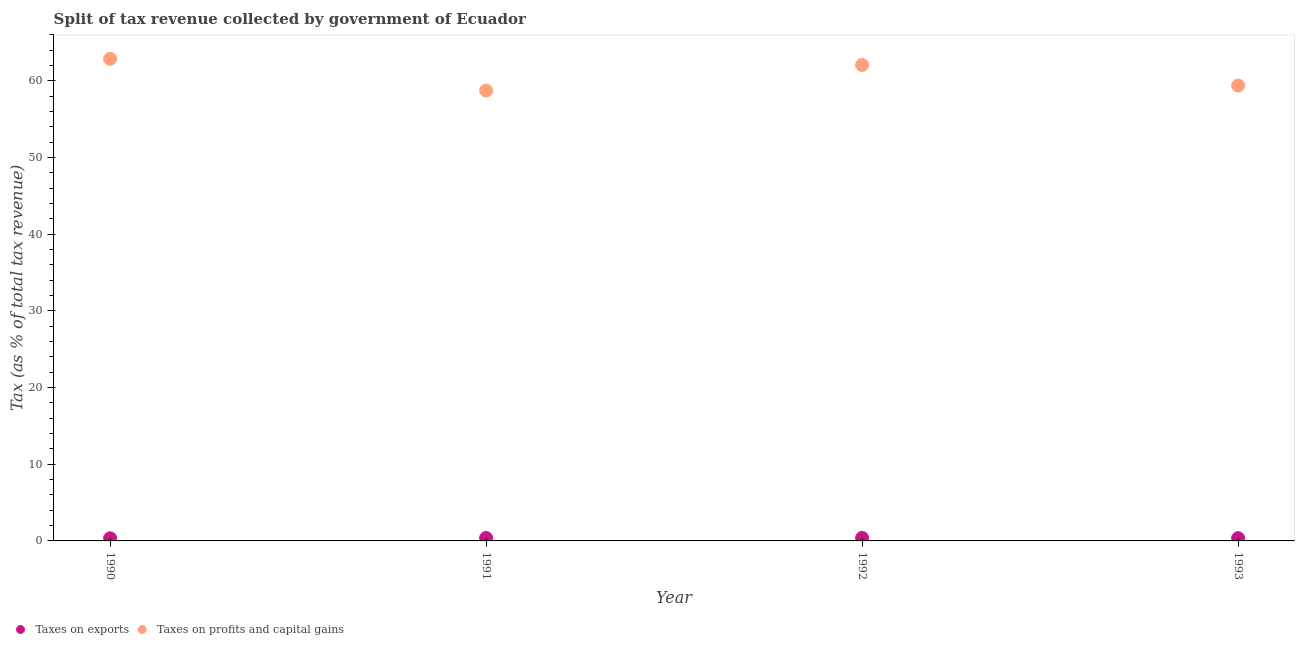How many different coloured dotlines are there?
Your answer should be compact. 2. Is the number of dotlines equal to the number of legend labels?
Your response must be concise. Yes. What is the percentage of revenue obtained from taxes on profits and capital gains in 1991?
Give a very brief answer. 58.74. Across all years, what is the maximum percentage of revenue obtained from taxes on profits and capital gains?
Your answer should be compact. 62.88. Across all years, what is the minimum percentage of revenue obtained from taxes on exports?
Your answer should be very brief. 0.34. In which year was the percentage of revenue obtained from taxes on profits and capital gains minimum?
Make the answer very short. 1991. What is the total percentage of revenue obtained from taxes on profits and capital gains in the graph?
Provide a short and direct response. 243.09. What is the difference between the percentage of revenue obtained from taxes on exports in 1990 and that in 1992?
Your response must be concise. -0.05. What is the difference between the percentage of revenue obtained from taxes on profits and capital gains in 1993 and the percentage of revenue obtained from taxes on exports in 1992?
Provide a succinct answer. 59. What is the average percentage of revenue obtained from taxes on profits and capital gains per year?
Keep it short and to the point. 60.77. In the year 1991, what is the difference between the percentage of revenue obtained from taxes on profits and capital gains and percentage of revenue obtained from taxes on exports?
Provide a succinct answer. 58.36. In how many years, is the percentage of revenue obtained from taxes on profits and capital gains greater than 4 %?
Provide a short and direct response. 4. What is the ratio of the percentage of revenue obtained from taxes on exports in 1992 to that in 1993?
Give a very brief answer. 1.1. Is the percentage of revenue obtained from taxes on exports in 1992 less than that in 1993?
Your response must be concise. No. What is the difference between the highest and the second highest percentage of revenue obtained from taxes on profits and capital gains?
Keep it short and to the point. 0.8. What is the difference between the highest and the lowest percentage of revenue obtained from taxes on profits and capital gains?
Your response must be concise. 4.14. Is the sum of the percentage of revenue obtained from taxes on profits and capital gains in 1990 and 1991 greater than the maximum percentage of revenue obtained from taxes on exports across all years?
Your answer should be compact. Yes. Does the percentage of revenue obtained from taxes on profits and capital gains monotonically increase over the years?
Ensure brevity in your answer.  No. Is the percentage of revenue obtained from taxes on exports strictly greater than the percentage of revenue obtained from taxes on profits and capital gains over the years?
Ensure brevity in your answer.  No. Is the percentage of revenue obtained from taxes on exports strictly less than the percentage of revenue obtained from taxes on profits and capital gains over the years?
Give a very brief answer. Yes. How many dotlines are there?
Provide a succinct answer. 2. How many years are there in the graph?
Make the answer very short. 4. Does the graph contain any zero values?
Offer a terse response. No. Where does the legend appear in the graph?
Ensure brevity in your answer.  Bottom left. What is the title of the graph?
Offer a very short reply. Split of tax revenue collected by government of Ecuador. What is the label or title of the Y-axis?
Give a very brief answer. Tax (as % of total tax revenue). What is the Tax (as % of total tax revenue) in Taxes on exports in 1990?
Offer a terse response. 0.34. What is the Tax (as % of total tax revenue) in Taxes on profits and capital gains in 1990?
Your response must be concise. 62.88. What is the Tax (as % of total tax revenue) in Taxes on exports in 1991?
Provide a short and direct response. 0.38. What is the Tax (as % of total tax revenue) of Taxes on profits and capital gains in 1991?
Offer a very short reply. 58.74. What is the Tax (as % of total tax revenue) in Taxes on exports in 1992?
Ensure brevity in your answer.  0.4. What is the Tax (as % of total tax revenue) of Taxes on profits and capital gains in 1992?
Offer a terse response. 62.08. What is the Tax (as % of total tax revenue) of Taxes on exports in 1993?
Your answer should be compact. 0.36. What is the Tax (as % of total tax revenue) of Taxes on profits and capital gains in 1993?
Ensure brevity in your answer.  59.4. Across all years, what is the maximum Tax (as % of total tax revenue) of Taxes on exports?
Keep it short and to the point. 0.4. Across all years, what is the maximum Tax (as % of total tax revenue) in Taxes on profits and capital gains?
Make the answer very short. 62.88. Across all years, what is the minimum Tax (as % of total tax revenue) of Taxes on exports?
Your answer should be compact. 0.34. Across all years, what is the minimum Tax (as % of total tax revenue) of Taxes on profits and capital gains?
Your response must be concise. 58.74. What is the total Tax (as % of total tax revenue) of Taxes on exports in the graph?
Provide a succinct answer. 1.48. What is the total Tax (as % of total tax revenue) in Taxes on profits and capital gains in the graph?
Ensure brevity in your answer.  243.09. What is the difference between the Tax (as % of total tax revenue) in Taxes on exports in 1990 and that in 1991?
Offer a terse response. -0.04. What is the difference between the Tax (as % of total tax revenue) of Taxes on profits and capital gains in 1990 and that in 1991?
Provide a short and direct response. 4.14. What is the difference between the Tax (as % of total tax revenue) of Taxes on exports in 1990 and that in 1992?
Give a very brief answer. -0.05. What is the difference between the Tax (as % of total tax revenue) in Taxes on profits and capital gains in 1990 and that in 1992?
Your answer should be very brief. 0.8. What is the difference between the Tax (as % of total tax revenue) in Taxes on exports in 1990 and that in 1993?
Offer a terse response. -0.02. What is the difference between the Tax (as % of total tax revenue) of Taxes on profits and capital gains in 1990 and that in 1993?
Ensure brevity in your answer.  3.48. What is the difference between the Tax (as % of total tax revenue) in Taxes on exports in 1991 and that in 1992?
Ensure brevity in your answer.  -0.02. What is the difference between the Tax (as % of total tax revenue) in Taxes on profits and capital gains in 1991 and that in 1992?
Give a very brief answer. -3.34. What is the difference between the Tax (as % of total tax revenue) of Taxes on exports in 1991 and that in 1993?
Ensure brevity in your answer.  0.02. What is the difference between the Tax (as % of total tax revenue) of Taxes on profits and capital gains in 1991 and that in 1993?
Your answer should be compact. -0.66. What is the difference between the Tax (as % of total tax revenue) of Taxes on exports in 1992 and that in 1993?
Your answer should be compact. 0.04. What is the difference between the Tax (as % of total tax revenue) of Taxes on profits and capital gains in 1992 and that in 1993?
Offer a very short reply. 2.68. What is the difference between the Tax (as % of total tax revenue) of Taxes on exports in 1990 and the Tax (as % of total tax revenue) of Taxes on profits and capital gains in 1991?
Your answer should be very brief. -58.4. What is the difference between the Tax (as % of total tax revenue) of Taxes on exports in 1990 and the Tax (as % of total tax revenue) of Taxes on profits and capital gains in 1992?
Your answer should be very brief. -61.74. What is the difference between the Tax (as % of total tax revenue) in Taxes on exports in 1990 and the Tax (as % of total tax revenue) in Taxes on profits and capital gains in 1993?
Offer a terse response. -59.05. What is the difference between the Tax (as % of total tax revenue) in Taxes on exports in 1991 and the Tax (as % of total tax revenue) in Taxes on profits and capital gains in 1992?
Your answer should be compact. -61.7. What is the difference between the Tax (as % of total tax revenue) of Taxes on exports in 1991 and the Tax (as % of total tax revenue) of Taxes on profits and capital gains in 1993?
Your answer should be compact. -59.02. What is the difference between the Tax (as % of total tax revenue) in Taxes on exports in 1992 and the Tax (as % of total tax revenue) in Taxes on profits and capital gains in 1993?
Keep it short and to the point. -59. What is the average Tax (as % of total tax revenue) in Taxes on exports per year?
Ensure brevity in your answer.  0.37. What is the average Tax (as % of total tax revenue) in Taxes on profits and capital gains per year?
Keep it short and to the point. 60.77. In the year 1990, what is the difference between the Tax (as % of total tax revenue) of Taxes on exports and Tax (as % of total tax revenue) of Taxes on profits and capital gains?
Your response must be concise. -62.53. In the year 1991, what is the difference between the Tax (as % of total tax revenue) of Taxes on exports and Tax (as % of total tax revenue) of Taxes on profits and capital gains?
Ensure brevity in your answer.  -58.36. In the year 1992, what is the difference between the Tax (as % of total tax revenue) of Taxes on exports and Tax (as % of total tax revenue) of Taxes on profits and capital gains?
Provide a succinct answer. -61.68. In the year 1993, what is the difference between the Tax (as % of total tax revenue) in Taxes on exports and Tax (as % of total tax revenue) in Taxes on profits and capital gains?
Offer a terse response. -59.04. What is the ratio of the Tax (as % of total tax revenue) in Taxes on exports in 1990 to that in 1991?
Ensure brevity in your answer.  0.9. What is the ratio of the Tax (as % of total tax revenue) of Taxes on profits and capital gains in 1990 to that in 1991?
Your response must be concise. 1.07. What is the ratio of the Tax (as % of total tax revenue) of Taxes on exports in 1990 to that in 1992?
Ensure brevity in your answer.  0.86. What is the ratio of the Tax (as % of total tax revenue) in Taxes on profits and capital gains in 1990 to that in 1992?
Make the answer very short. 1.01. What is the ratio of the Tax (as % of total tax revenue) in Taxes on exports in 1990 to that in 1993?
Your response must be concise. 0.95. What is the ratio of the Tax (as % of total tax revenue) in Taxes on profits and capital gains in 1990 to that in 1993?
Make the answer very short. 1.06. What is the ratio of the Tax (as % of total tax revenue) in Taxes on exports in 1991 to that in 1992?
Ensure brevity in your answer.  0.96. What is the ratio of the Tax (as % of total tax revenue) of Taxes on profits and capital gains in 1991 to that in 1992?
Your answer should be compact. 0.95. What is the ratio of the Tax (as % of total tax revenue) of Taxes on exports in 1991 to that in 1993?
Offer a very short reply. 1.06. What is the ratio of the Tax (as % of total tax revenue) in Taxes on profits and capital gains in 1991 to that in 1993?
Ensure brevity in your answer.  0.99. What is the ratio of the Tax (as % of total tax revenue) in Taxes on exports in 1992 to that in 1993?
Your answer should be compact. 1.1. What is the ratio of the Tax (as % of total tax revenue) of Taxes on profits and capital gains in 1992 to that in 1993?
Ensure brevity in your answer.  1.05. What is the difference between the highest and the second highest Tax (as % of total tax revenue) of Taxes on exports?
Your response must be concise. 0.02. What is the difference between the highest and the second highest Tax (as % of total tax revenue) of Taxes on profits and capital gains?
Make the answer very short. 0.8. What is the difference between the highest and the lowest Tax (as % of total tax revenue) of Taxes on exports?
Give a very brief answer. 0.05. What is the difference between the highest and the lowest Tax (as % of total tax revenue) of Taxes on profits and capital gains?
Provide a succinct answer. 4.14. 